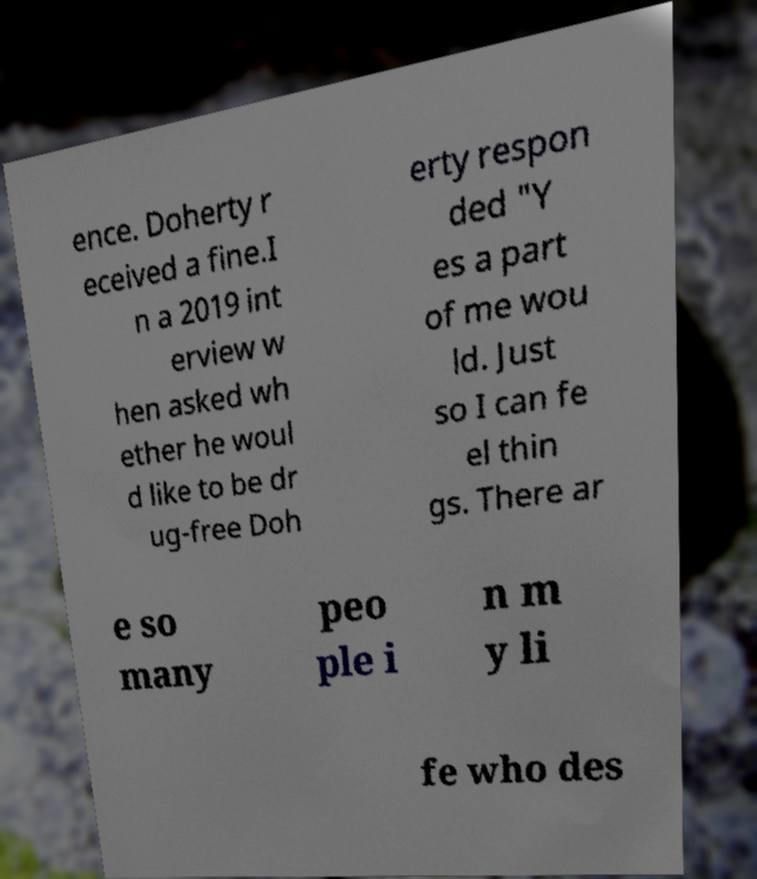Please read and relay the text visible in this image. What does it say? ence. Doherty r eceived a fine.I n a 2019 int erview w hen asked wh ether he woul d like to be dr ug-free Doh erty respon ded "Y es a part of me wou ld. Just so I can fe el thin gs. There ar e so many peo ple i n m y li fe who des 